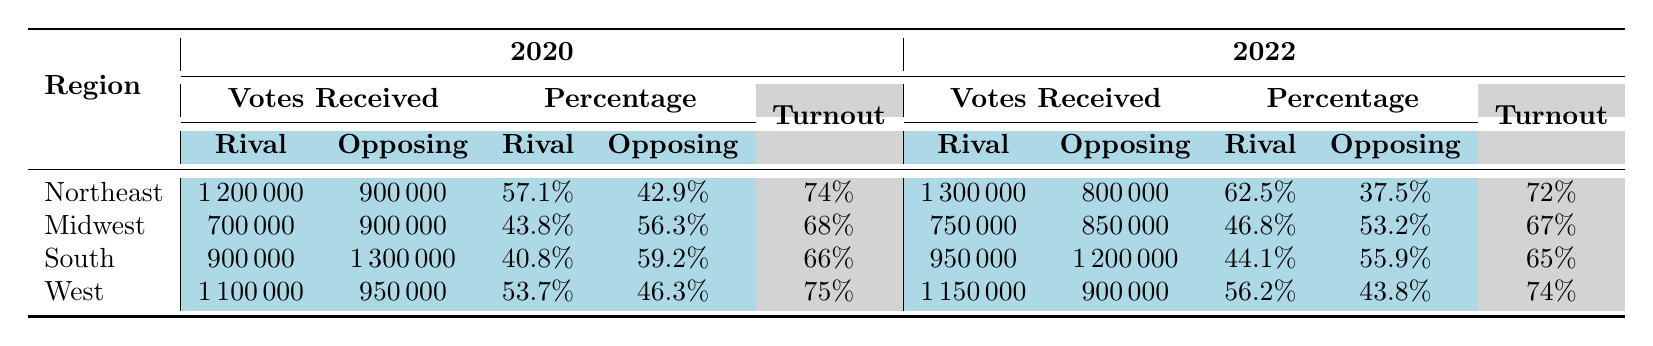What was the total number of votes received by the Rival Party in the Northeast region in 2022? The table indicates that in the Northeast region for 2022, the Rival Party received 1,300,000 votes.
Answer: 1,300,000 Which region had the highest voter turnout in 2020? The table shows that the West region had the highest voter turnout at 75% in 2020.
Answer: West What is the difference in the percentage of votes received by the Rival Party between 2020 and 2022 in the Midwest region? The percentage for the Rival Party in the Midwest region was 43.8% in 2020 and 46.8% in 2022. The difference is 46.8% - 43.8% = 3%.
Answer: 3% Did the Rival Party receive more votes than the Opposing Party in the South region in 2020? According to the table, the Rival Party received 900,000 votes while the Opposing Party received 1,300,000 votes in the South region in 2020, indicating that the Rival Party received fewer votes.
Answer: No What was the average voter turnout of all regions in 2022? The voter turnouts in 2022 for each region are 72% (Northeast), 67% (Midwest), 65% (South), and 74% (West). Summing these gives 72 + 67 + 65 + 74 = 278. Dividing by 4 (the number of regions) gives 278/4 = 69.5%.
Answer: 69.5% In which year did the Rival Party see a higher percentage of votes in the Northeast region? The percentages in the Northeast were 57.1% in 2020 and 62.5% in 2022. The Rival Party had a higher percentage in 2022 with 62.5%.
Answer: 2022 What is the total number of votes received by the Rival Party across all regions in 2020? The total votes for the Rival Party in 2020 are 1,200,000 (Northeast) + 700,000 (Midwest) + 900,000 (South) + 1,100,000 (West) = 3,900,000.
Answer: 3,900,000 Is it true that the Opposing Party received more votes than the Rival Party in all regions for 2020? The Opposing Party received more votes than the Rival Party in the South (1,300,000 vs. 900,000) and the Midwest (900,000 vs. 700,000), but in the Northeast and West, the Rival Party received more votes. Therefore, it's false.
Answer: No What was the percentage increase of votes for the Rival Party from 2020 to 2022 in the West region? In the West region, the Rival Party received 53.7% in 2020 and 56.2% in 2022. The increase is 56.2% - 53.7% = 2.5%.
Answer: 2.5% How does the voter turnout for the South region in 2020 compare to 2022? The turnout for the South region decreased from 66% in 2020 to 65% in 2022, indicating a 1% decline.
Answer: Decreased by 1% 